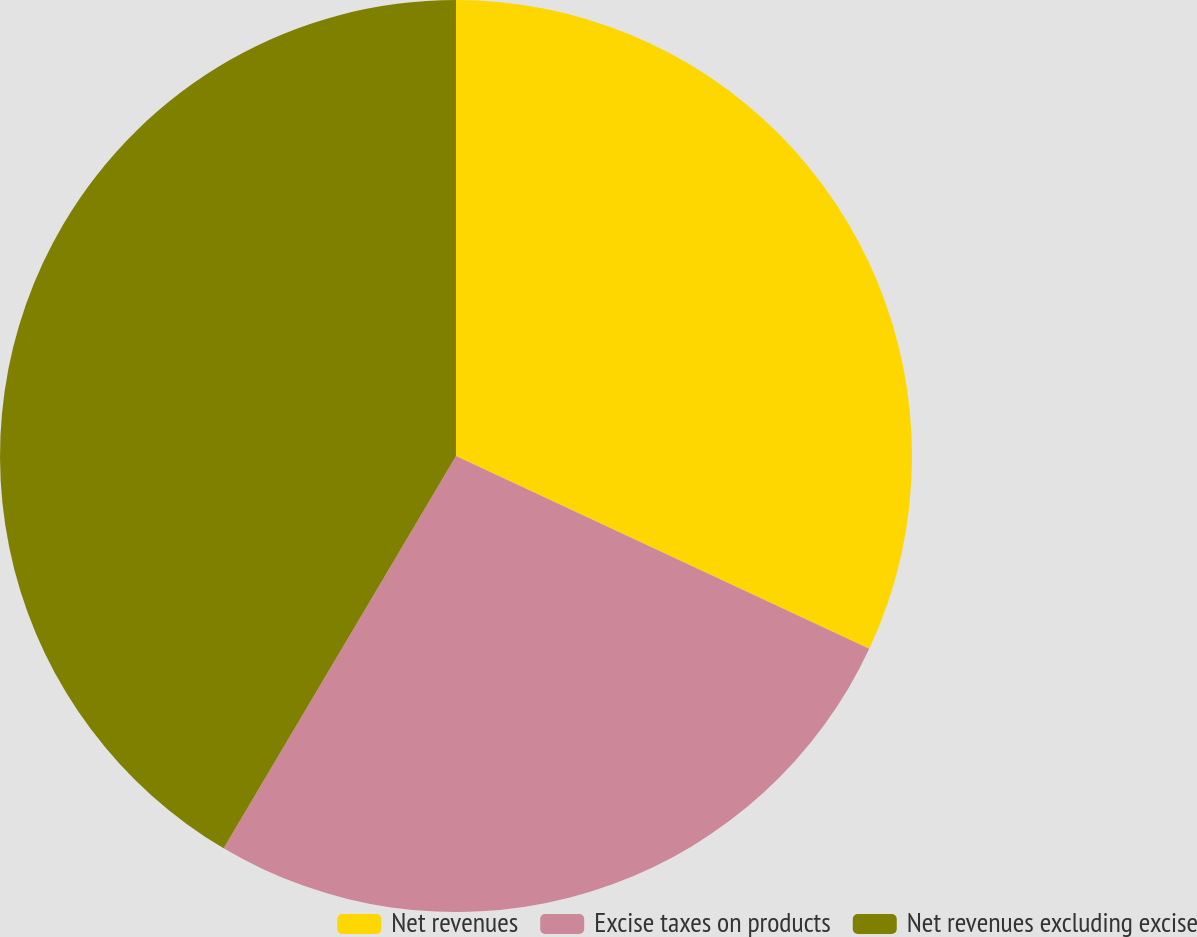Convert chart to OTSL. <chart><loc_0><loc_0><loc_500><loc_500><pie_chart><fcel>Net revenues<fcel>Excise taxes on products<fcel>Net revenues excluding excise<nl><fcel>31.95%<fcel>26.56%<fcel>41.49%<nl></chart> 